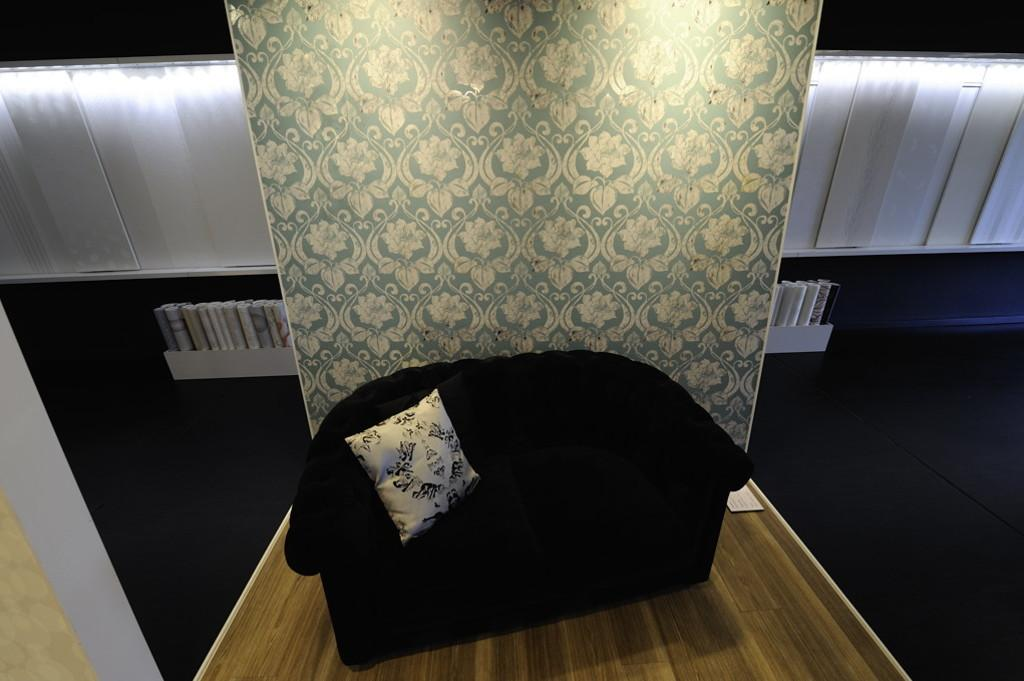What type of furniture is in the image? There is a black couch in the image. What is on the couch? There is a pillow on the couch. What material is the floor made of? The floor is wooden. What can be seen in the background of the image? There is a wall and lights in the background of the image. Are there any other objects visible in the image? Yes, there are additional objects visible in the image. What type of leaf is being used to soothe the person's throat in the image? There is no leaf or person with a sore throat present in the image. How is the lock being used in the image? There is no lock present in the image. 